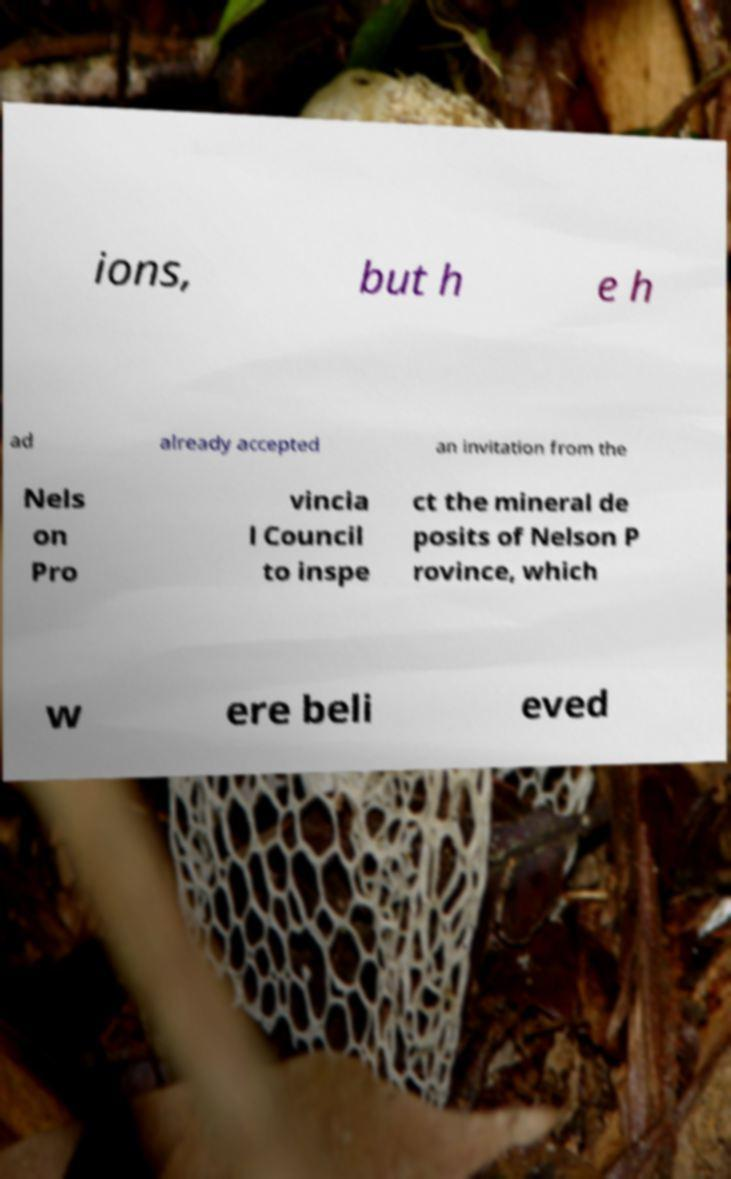Please identify and transcribe the text found in this image. ions, but h e h ad already accepted an invitation from the Nels on Pro vincia l Council to inspe ct the mineral de posits of Nelson P rovince, which w ere beli eved 